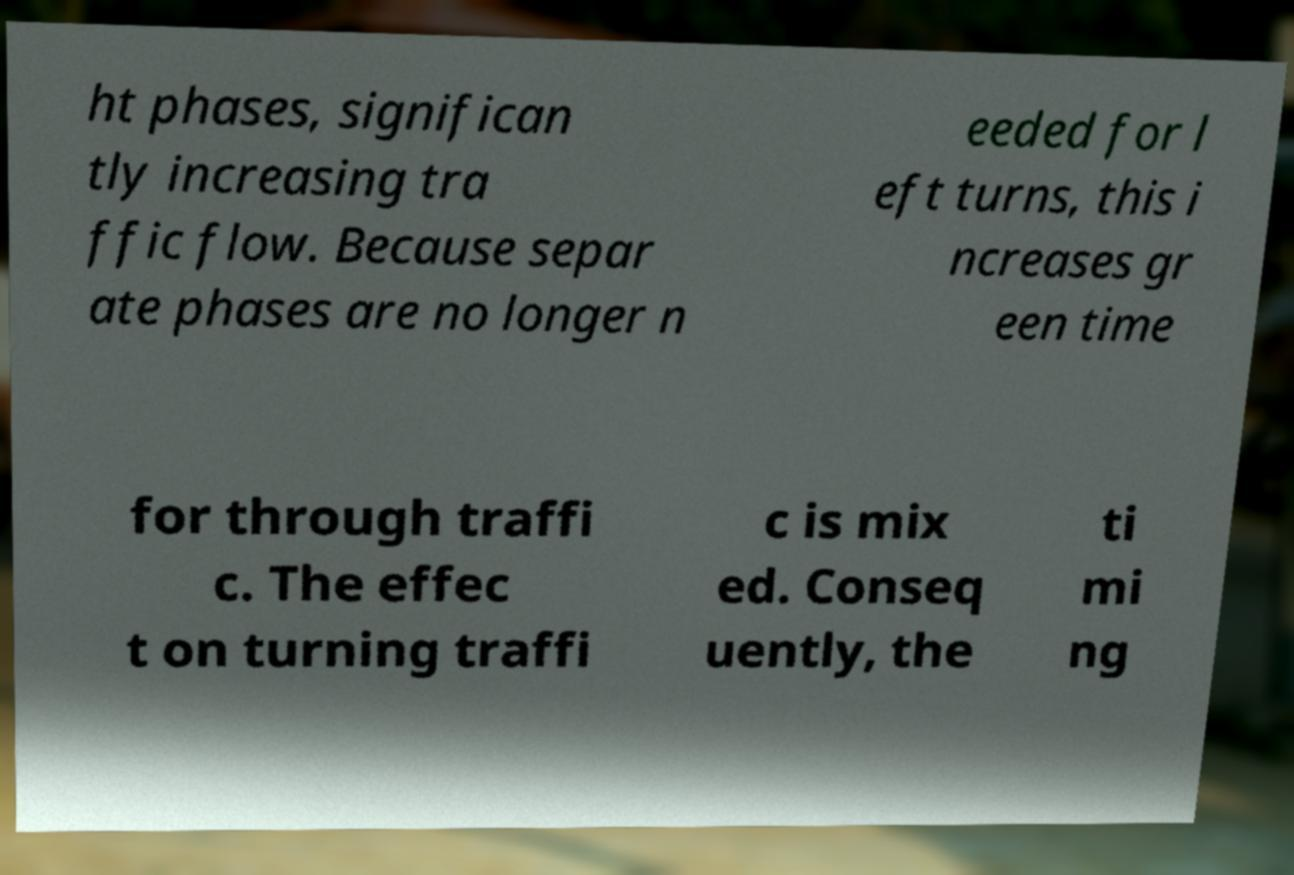For documentation purposes, I need the text within this image transcribed. Could you provide that? ht phases, significan tly increasing tra ffic flow. Because separ ate phases are no longer n eeded for l eft turns, this i ncreases gr een time for through traffi c. The effec t on turning traffi c is mix ed. Conseq uently, the ti mi ng 